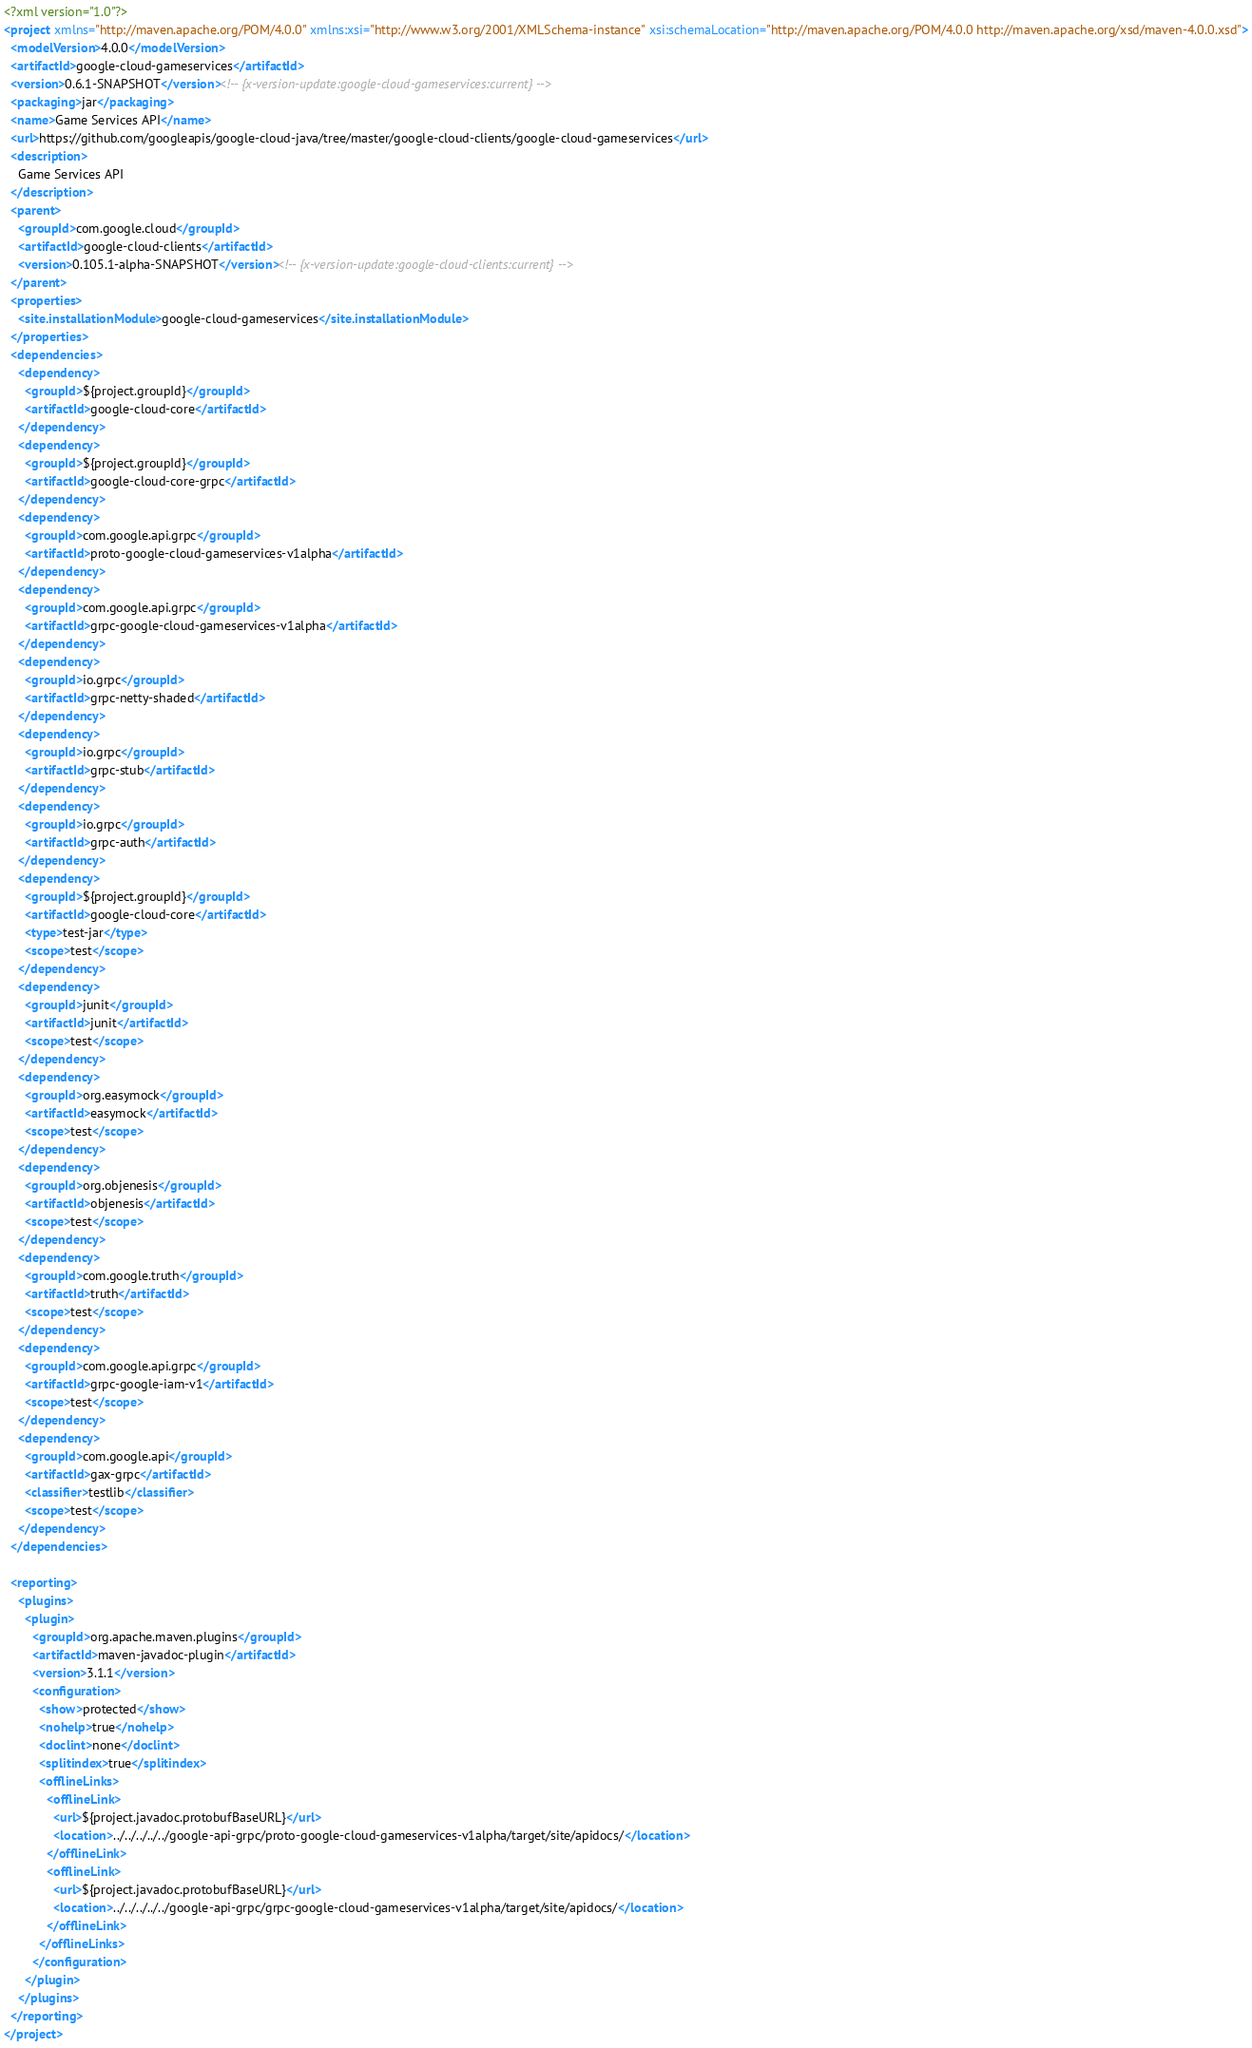Convert code to text. <code><loc_0><loc_0><loc_500><loc_500><_XML_><?xml version="1.0"?>
<project xmlns="http://maven.apache.org/POM/4.0.0" xmlns:xsi="http://www.w3.org/2001/XMLSchema-instance" xsi:schemaLocation="http://maven.apache.org/POM/4.0.0 http://maven.apache.org/xsd/maven-4.0.0.xsd">
  <modelVersion>4.0.0</modelVersion>
  <artifactId>google-cloud-gameservices</artifactId>
  <version>0.6.1-SNAPSHOT</version><!-- {x-version-update:google-cloud-gameservices:current} -->
  <packaging>jar</packaging>
  <name>Game Services API</name>
  <url>https://github.com/googleapis/google-cloud-java/tree/master/google-cloud-clients/google-cloud-gameservices</url>
  <description>
    Game Services API
  </description>
  <parent>
    <groupId>com.google.cloud</groupId>
    <artifactId>google-cloud-clients</artifactId>
    <version>0.105.1-alpha-SNAPSHOT</version><!-- {x-version-update:google-cloud-clients:current} -->
  </parent>
  <properties>
    <site.installationModule>google-cloud-gameservices</site.installationModule>
  </properties>
  <dependencies>
    <dependency>
      <groupId>${project.groupId}</groupId>
      <artifactId>google-cloud-core</artifactId>
    </dependency>
    <dependency>
      <groupId>${project.groupId}</groupId>
      <artifactId>google-cloud-core-grpc</artifactId>
    </dependency>
    <dependency>
      <groupId>com.google.api.grpc</groupId>
      <artifactId>proto-google-cloud-gameservices-v1alpha</artifactId>
    </dependency>
    <dependency>
      <groupId>com.google.api.grpc</groupId>
      <artifactId>grpc-google-cloud-gameservices-v1alpha</artifactId>
    </dependency>
    <dependency>
      <groupId>io.grpc</groupId>
      <artifactId>grpc-netty-shaded</artifactId>
    </dependency>
    <dependency>
      <groupId>io.grpc</groupId>
      <artifactId>grpc-stub</artifactId>
    </dependency>
    <dependency>
      <groupId>io.grpc</groupId>
      <artifactId>grpc-auth</artifactId>
    </dependency>
    <dependency>
      <groupId>${project.groupId}</groupId>
      <artifactId>google-cloud-core</artifactId>
      <type>test-jar</type>
      <scope>test</scope>
    </dependency>
    <dependency>
      <groupId>junit</groupId>
      <artifactId>junit</artifactId>
      <scope>test</scope>
    </dependency>
    <dependency>
      <groupId>org.easymock</groupId>
      <artifactId>easymock</artifactId>
      <scope>test</scope>
    </dependency>
    <dependency>
      <groupId>org.objenesis</groupId>
      <artifactId>objenesis</artifactId>
      <scope>test</scope>
    </dependency>
    <dependency>
      <groupId>com.google.truth</groupId>
      <artifactId>truth</artifactId>
      <scope>test</scope>
    </dependency>
    <dependency>
      <groupId>com.google.api.grpc</groupId>
      <artifactId>grpc-google-iam-v1</artifactId>
      <scope>test</scope>
    </dependency>
    <dependency>
      <groupId>com.google.api</groupId>
      <artifactId>gax-grpc</artifactId>
      <classifier>testlib</classifier>
      <scope>test</scope>
    </dependency>
  </dependencies>

  <reporting>
    <plugins>
      <plugin>
        <groupId>org.apache.maven.plugins</groupId>
        <artifactId>maven-javadoc-plugin</artifactId>
        <version>3.1.1</version>
        <configuration>
          <show>protected</show>
          <nohelp>true</nohelp>
          <doclint>none</doclint>
          <splitindex>true</splitindex>
          <offlineLinks>
            <offlineLink>
              <url>${project.javadoc.protobufBaseURL}</url>
              <location>../../../../../google-api-grpc/proto-google-cloud-gameservices-v1alpha/target/site/apidocs/</location>
            </offlineLink>
            <offlineLink>
              <url>${project.javadoc.protobufBaseURL}</url>
              <location>../../../../../google-api-grpc/grpc-google-cloud-gameservices-v1alpha/target/site/apidocs/</location>
            </offlineLink>
          </offlineLinks>
        </configuration>
      </plugin>
    </plugins>
  </reporting>
</project>
</code> 